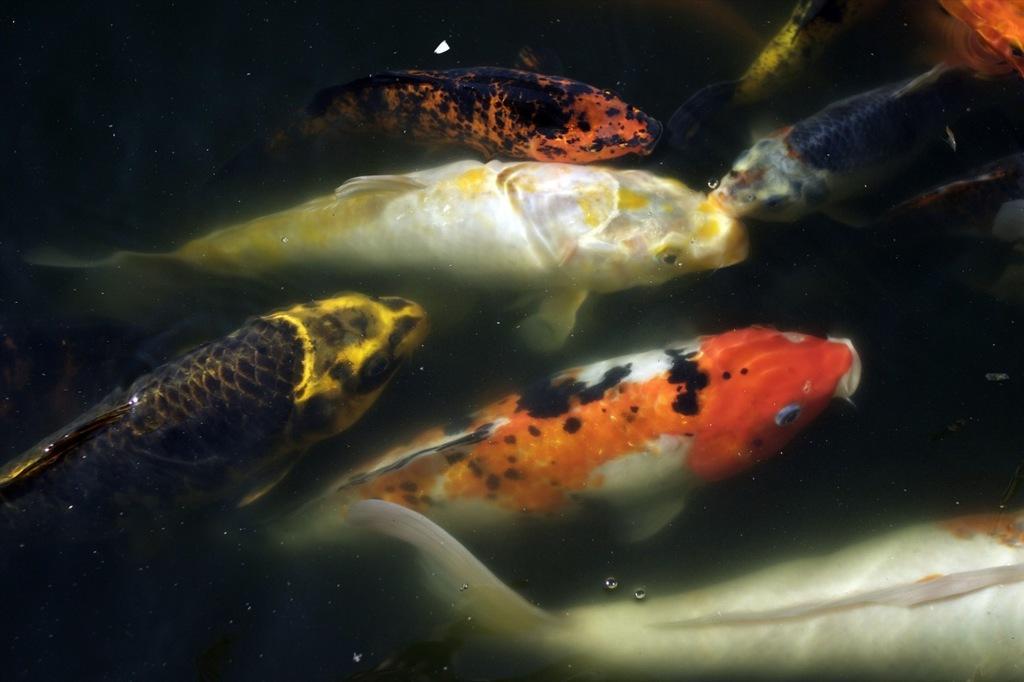In one or two sentences, can you explain what this image depicts? In this image I can see a fishes in water. They are in different color. 